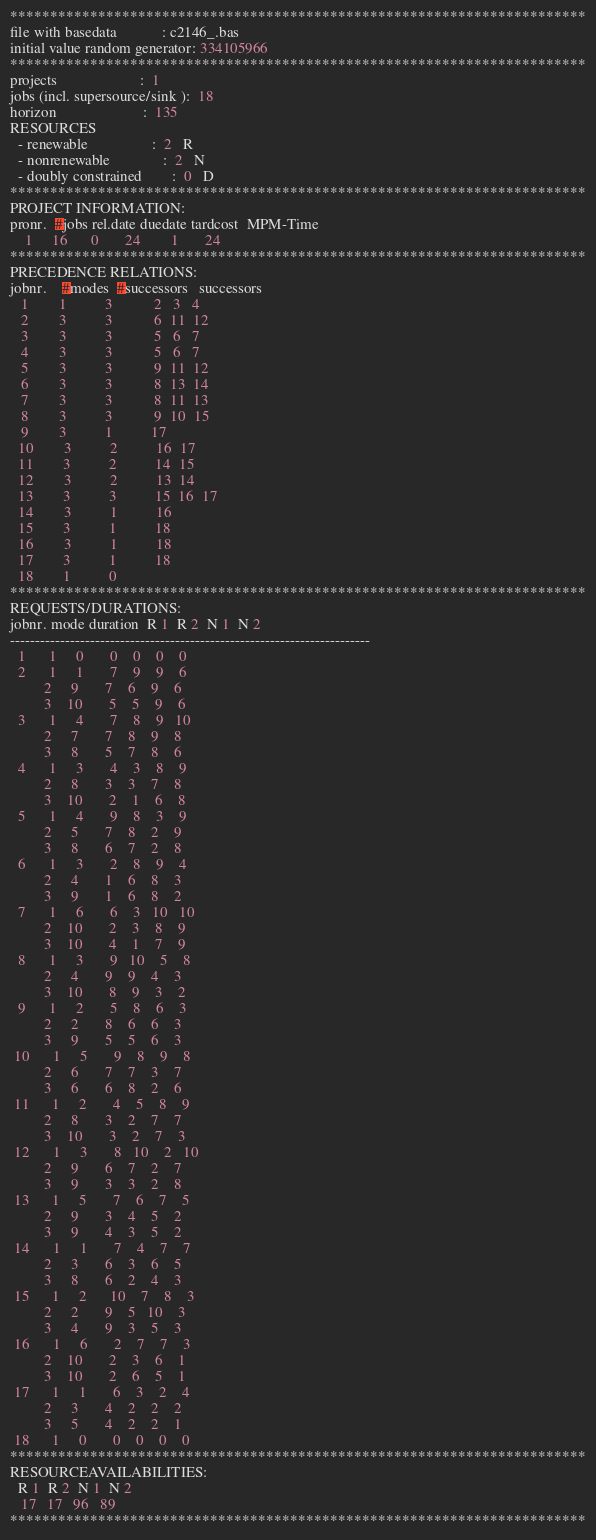Convert code to text. <code><loc_0><loc_0><loc_500><loc_500><_ObjectiveC_>************************************************************************
file with basedata            : c2146_.bas
initial value random generator: 334105966
************************************************************************
projects                      :  1
jobs (incl. supersource/sink ):  18
horizon                       :  135
RESOURCES
  - renewable                 :  2   R
  - nonrenewable              :  2   N
  - doubly constrained        :  0   D
************************************************************************
PROJECT INFORMATION:
pronr.  #jobs rel.date duedate tardcost  MPM-Time
    1     16      0       24        1       24
************************************************************************
PRECEDENCE RELATIONS:
jobnr.    #modes  #successors   successors
   1        1          3           2   3   4
   2        3          3           6  11  12
   3        3          3           5   6   7
   4        3          3           5   6   7
   5        3          3           9  11  12
   6        3          3           8  13  14
   7        3          3           8  11  13
   8        3          3           9  10  15
   9        3          1          17
  10        3          2          16  17
  11        3          2          14  15
  12        3          2          13  14
  13        3          3          15  16  17
  14        3          1          16
  15        3          1          18
  16        3          1          18
  17        3          1          18
  18        1          0        
************************************************************************
REQUESTS/DURATIONS:
jobnr. mode duration  R 1  R 2  N 1  N 2
------------------------------------------------------------------------
  1      1     0       0    0    0    0
  2      1     1       7    9    9    6
         2     9       7    6    9    6
         3    10       5    5    9    6
  3      1     4       7    8    9   10
         2     7       7    8    9    8
         3     8       5    7    8    6
  4      1     3       4    3    8    9
         2     8       3    3    7    8
         3    10       2    1    6    8
  5      1     4       9    8    3    9
         2     5       7    8    2    9
         3     8       6    7    2    8
  6      1     3       2    8    9    4
         2     4       1    6    8    3
         3     9       1    6    8    2
  7      1     6       6    3   10   10
         2    10       2    3    8    9
         3    10       4    1    7    9
  8      1     3       9   10    5    8
         2     4       9    9    4    3
         3    10       8    9    3    2
  9      1     2       5    8    6    3
         2     2       8    6    6    3
         3     9       5    5    6    3
 10      1     5       9    8    9    8
         2     6       7    7    3    7
         3     6       6    8    2    6
 11      1     2       4    5    8    9
         2     8       3    2    7    7
         3    10       3    2    7    3
 12      1     3       8   10    2   10
         2     9       6    7    2    7
         3     9       3    3    2    8
 13      1     5       7    6    7    5
         2     9       3    4    5    2
         3     9       4    3    5    2
 14      1     1       7    4    7    7
         2     3       6    3    6    5
         3     8       6    2    4    3
 15      1     2      10    7    8    3
         2     2       9    5   10    3
         3     4       9    3    5    3
 16      1     6       2    7    7    3
         2    10       2    3    6    1
         3    10       2    6    5    1
 17      1     1       6    3    2    4
         2     3       4    2    2    2
         3     5       4    2    2    1
 18      1     0       0    0    0    0
************************************************************************
RESOURCEAVAILABILITIES:
  R 1  R 2  N 1  N 2
   17   17   96   89
************************************************************************
</code> 